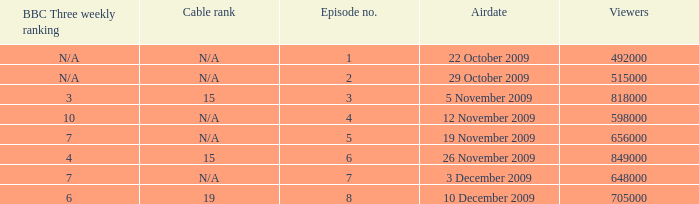What is the cable rank for bbc three weekly ranking of n/a? N/A, N/A. 